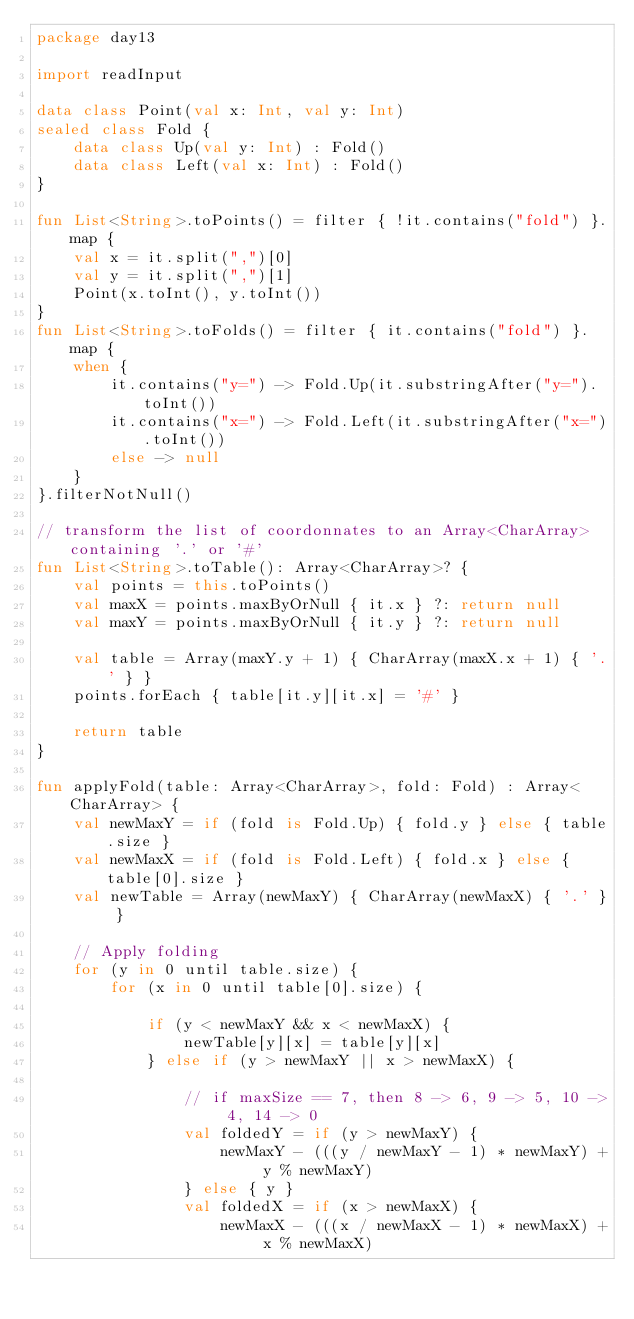<code> <loc_0><loc_0><loc_500><loc_500><_Kotlin_>package day13

import readInput

data class Point(val x: Int, val y: Int)
sealed class Fold {
    data class Up(val y: Int) : Fold()
    data class Left(val x: Int) : Fold()
}

fun List<String>.toPoints() = filter { !it.contains("fold") }.map {
    val x = it.split(",")[0]
    val y = it.split(",")[1]
    Point(x.toInt(), y.toInt())
}
fun List<String>.toFolds() = filter { it.contains("fold") }.map {
    when {
        it.contains("y=") -> Fold.Up(it.substringAfter("y=").toInt())
        it.contains("x=") -> Fold.Left(it.substringAfter("x=").toInt())
        else -> null
    }
}.filterNotNull()

// transform the list of coordonnates to an Array<CharArray> containing '.' or '#'
fun List<String>.toTable(): Array<CharArray>? {
    val points = this.toPoints()
    val maxX = points.maxByOrNull { it.x } ?: return null
    val maxY = points.maxByOrNull { it.y } ?: return null

    val table = Array(maxY.y + 1) { CharArray(maxX.x + 1) { '.' } }
    points.forEach { table[it.y][it.x] = '#' }

    return table
}

fun applyFold(table: Array<CharArray>, fold: Fold) : Array<CharArray> {
    val newMaxY = if (fold is Fold.Up) { fold.y } else { table.size }
    val newMaxX = if (fold is Fold.Left) { fold.x } else { table[0].size }
    val newTable = Array(newMaxY) { CharArray(newMaxX) { '.' } }

    // Apply folding
    for (y in 0 until table.size) {
        for (x in 0 until table[0].size) {

            if (y < newMaxY && x < newMaxX) {
                newTable[y][x] = table[y][x]
            } else if (y > newMaxY || x > newMaxX) {

                // if maxSize == 7, then 8 -> 6, 9 -> 5, 10 -> 4, 14 -> 0
                val foldedY = if (y > newMaxY) {
                    newMaxY - (((y / newMaxY - 1) * newMaxY) + y % newMaxY)
                } else { y }
                val foldedX = if (x > newMaxX) {
                    newMaxX - (((x / newMaxX - 1) * newMaxX) + x % newMaxX)</code> 